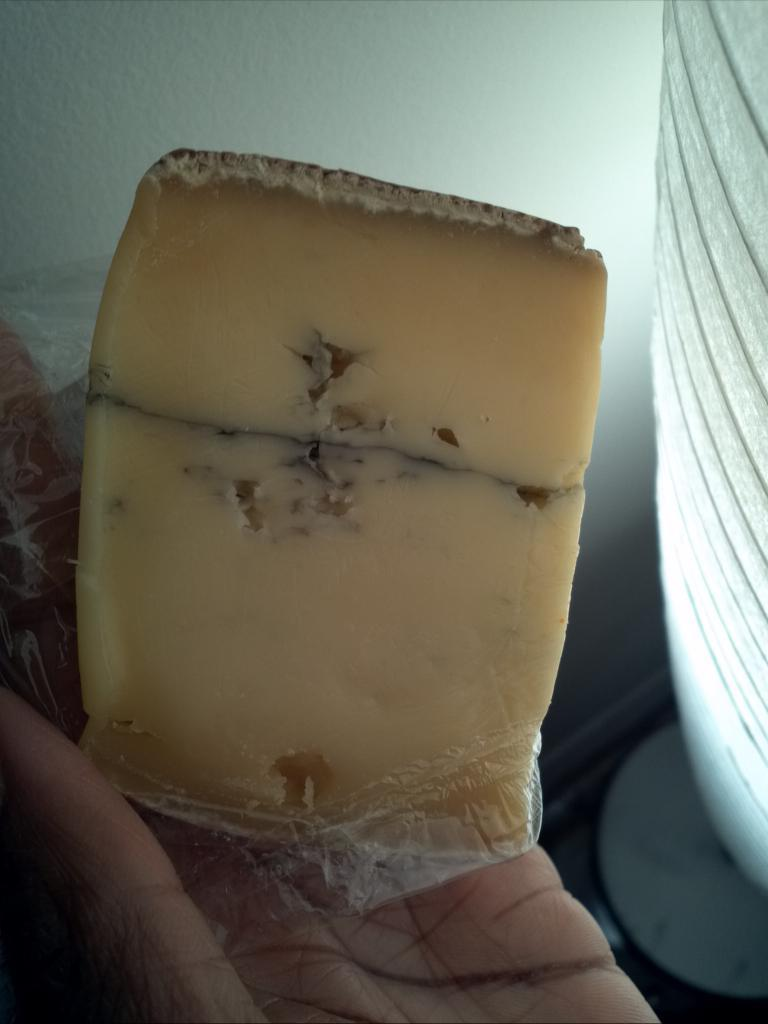Who or what is present in the image? There is a person in the image. What is the person doing in the image? The person is holding an object. Can you describe the object the person is holding? The object is in cream color. What can be seen behind the person in the image? The background of the image is a white wall. How many insects can be seen crawling on the dime in the image? There is no dime or insect present in the image. 